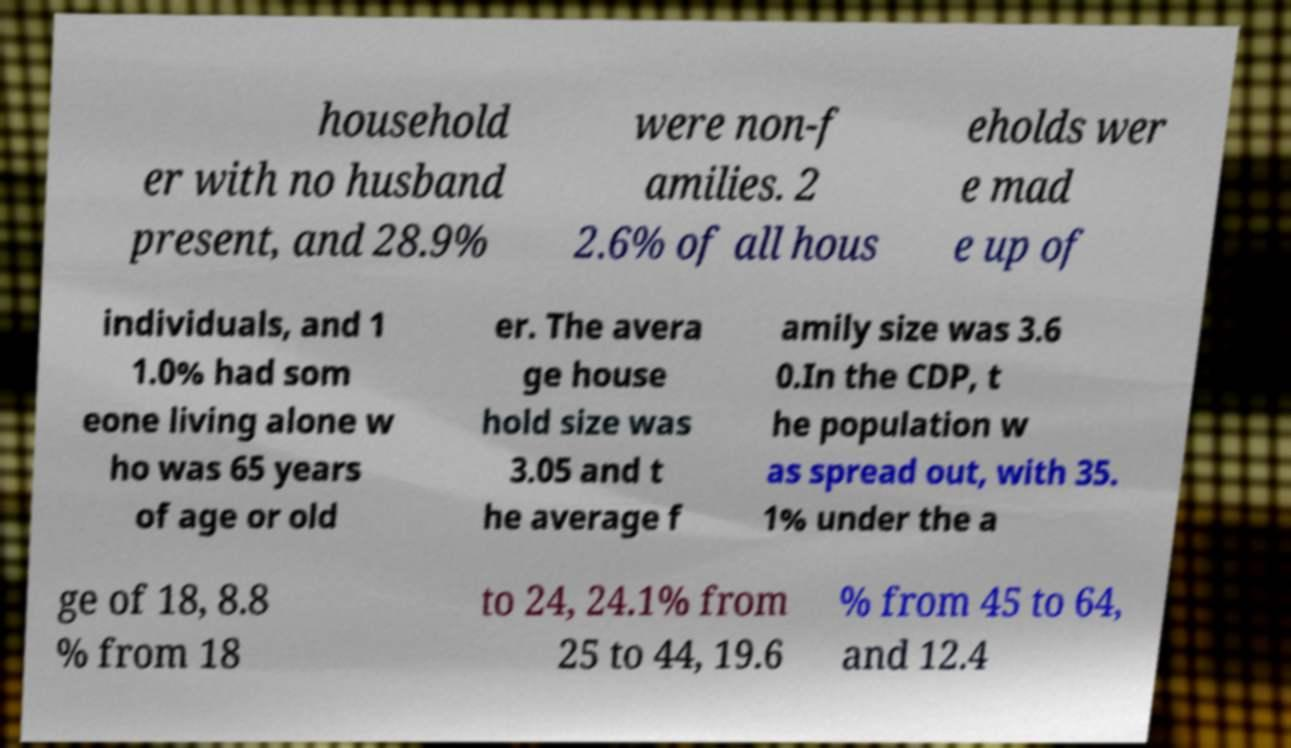Could you extract and type out the text from this image? household er with no husband present, and 28.9% were non-f amilies. 2 2.6% of all hous eholds wer e mad e up of individuals, and 1 1.0% had som eone living alone w ho was 65 years of age or old er. The avera ge house hold size was 3.05 and t he average f amily size was 3.6 0.In the CDP, t he population w as spread out, with 35. 1% under the a ge of 18, 8.8 % from 18 to 24, 24.1% from 25 to 44, 19.6 % from 45 to 64, and 12.4 